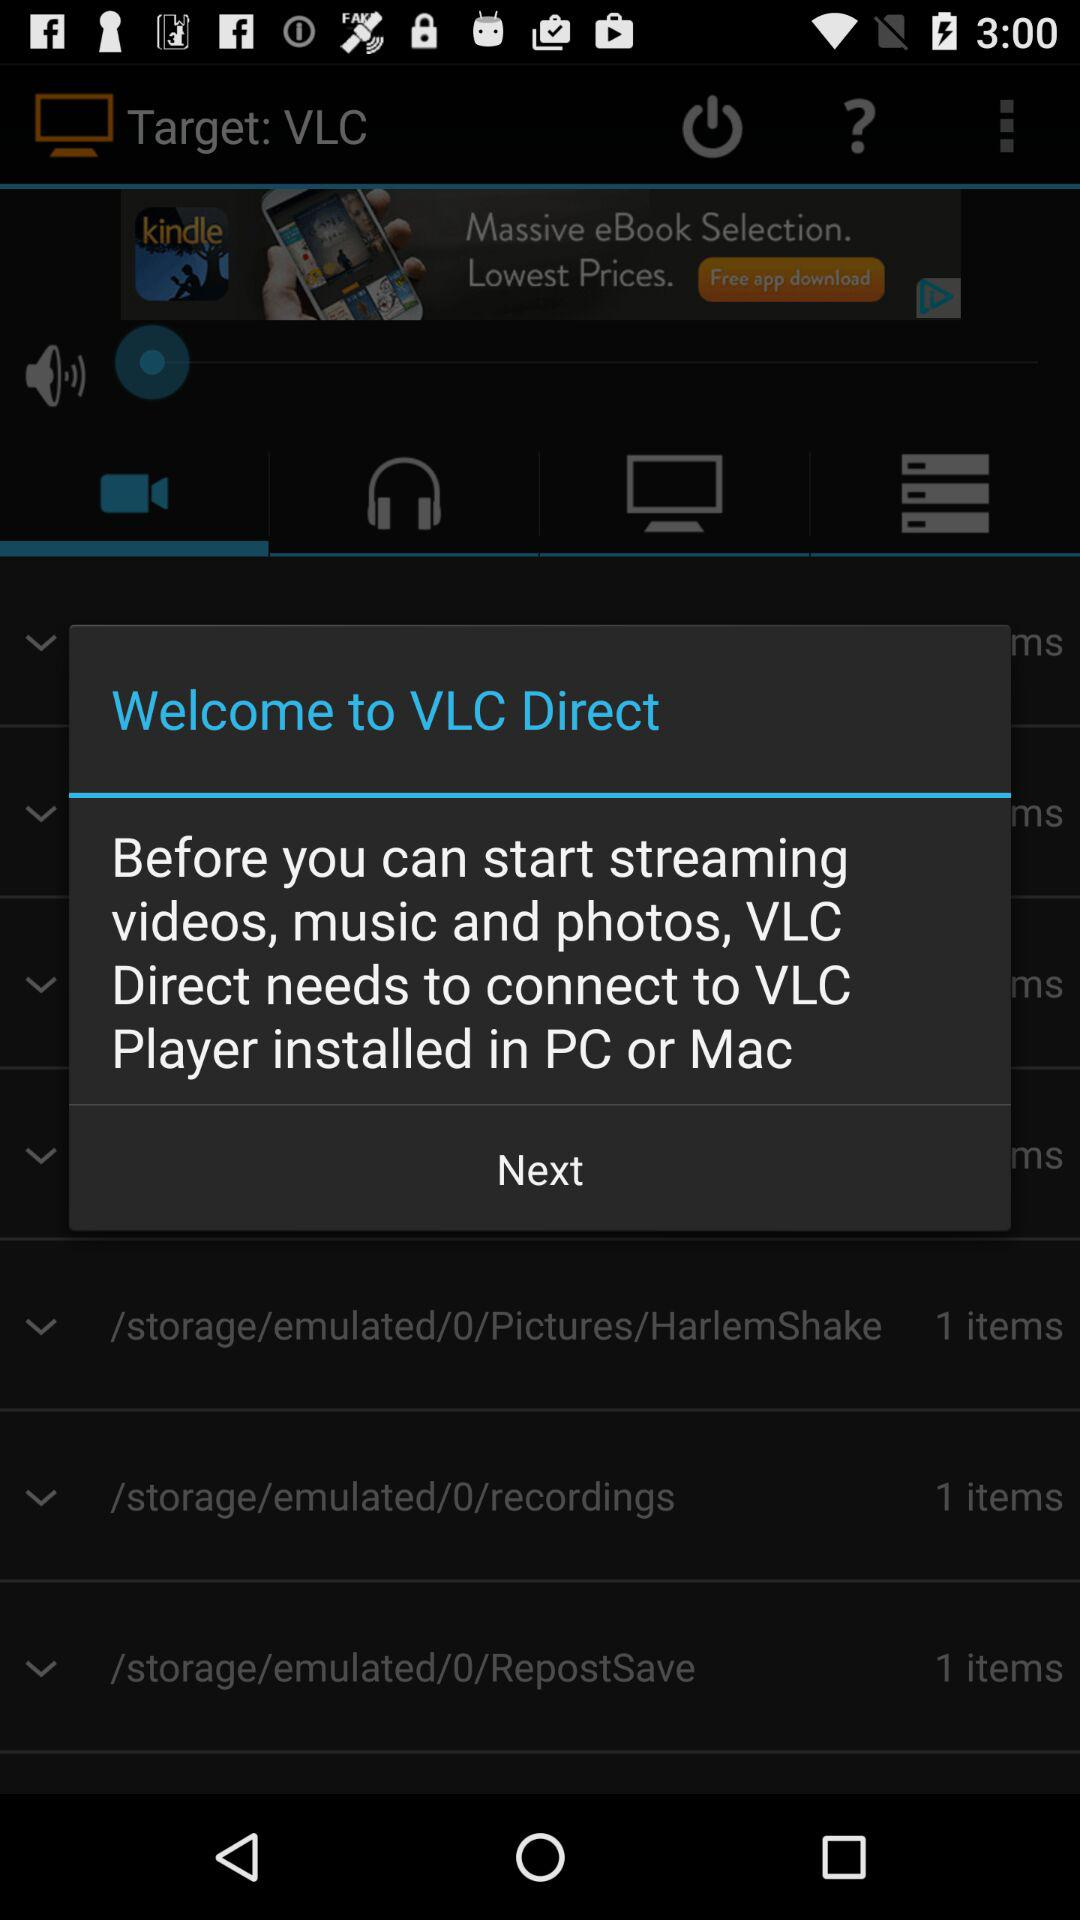What needs to be connected to "VLC Player" installed in a PC or Mac? The application "VLC Direct" needs to be connected to "VLC Player" installed in a PC or Mac. 